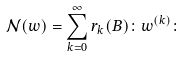Convert formula to latex. <formula><loc_0><loc_0><loc_500><loc_500>\mathcal { N } ( w ) = \sum _ { k = 0 } ^ { \infty } r _ { k } ( B ) \colon w ^ { ( k ) } \colon</formula> 